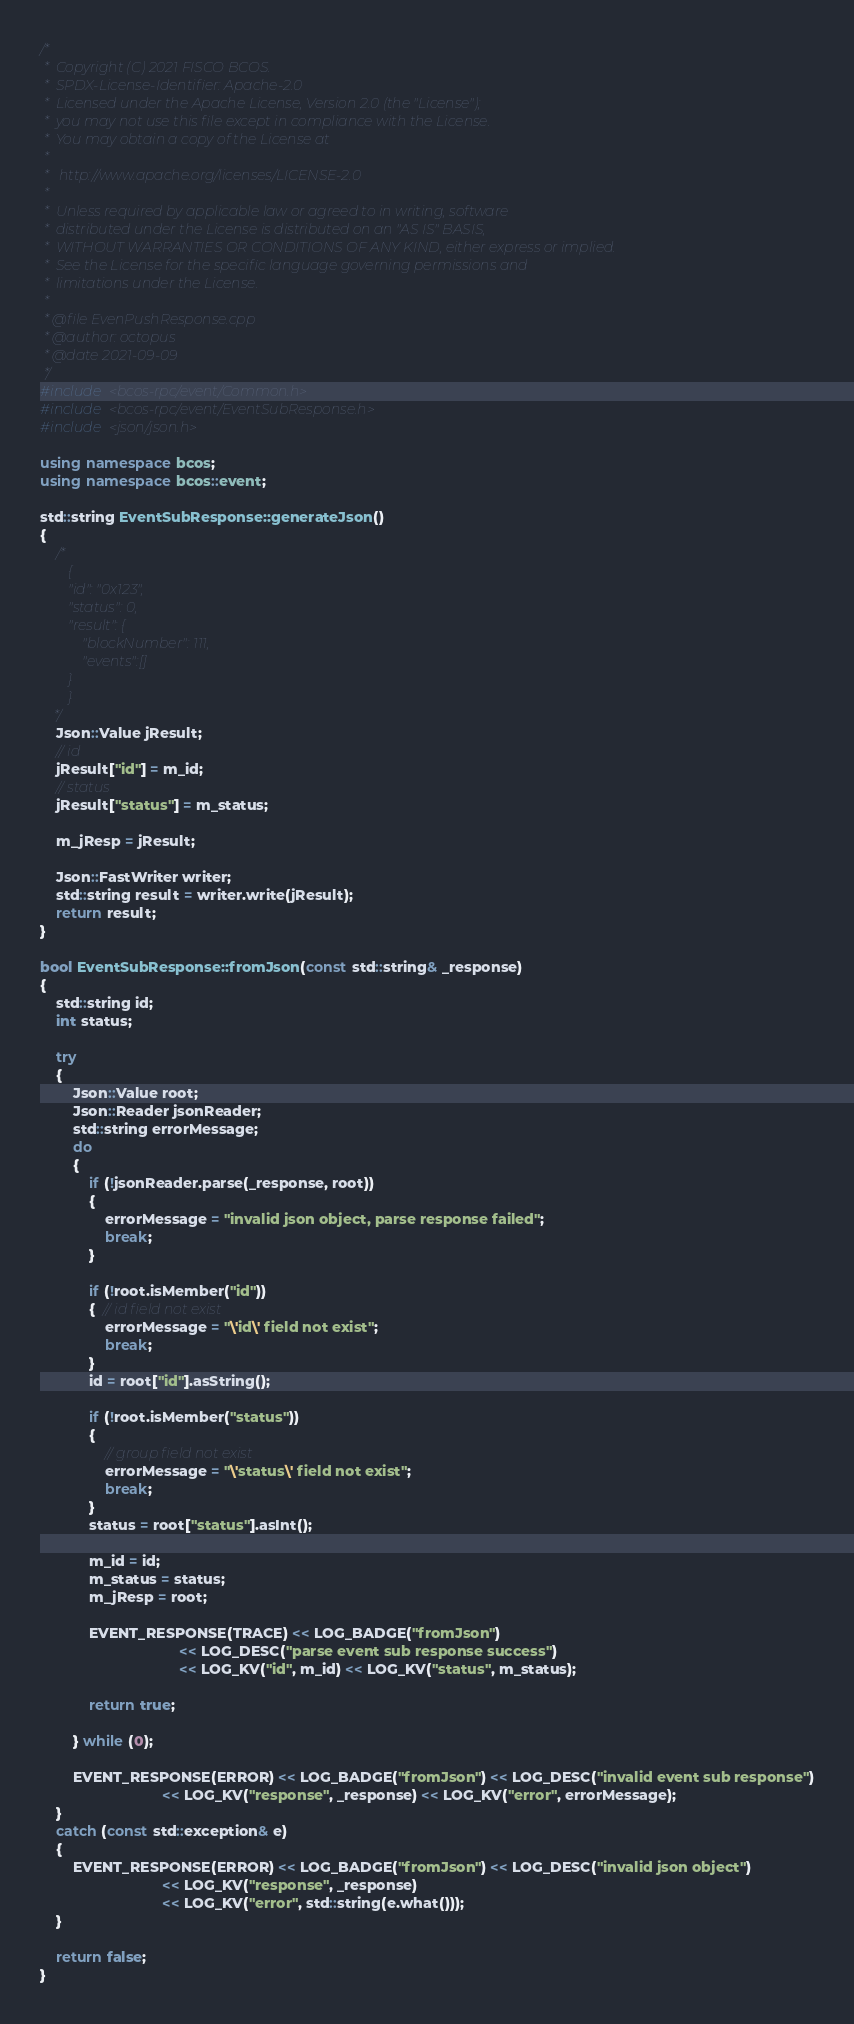Convert code to text. <code><loc_0><loc_0><loc_500><loc_500><_C++_>/*
 *  Copyright (C) 2021 FISCO BCOS.
 *  SPDX-License-Identifier: Apache-2.0
 *  Licensed under the Apache License, Version 2.0 (the "License");
 *  you may not use this file except in compliance with the License.
 *  You may obtain a copy of the License at
 *
 *   http://www.apache.org/licenses/LICENSE-2.0
 *
 *  Unless required by applicable law or agreed to in writing, software
 *  distributed under the License is distributed on an "AS IS" BASIS,
 *  WITHOUT WARRANTIES OR CONDITIONS OF ANY KIND, either express or implied.
 *  See the License for the specific language governing permissions and
 *  limitations under the License.
 *
 * @file EvenPushResponse.cpp
 * @author: octopus
 * @date 2021-09-09
 */
#include <bcos-rpc/event/Common.h>
#include <bcos-rpc/event/EventSubResponse.h>
#include <json/json.h>

using namespace bcos;
using namespace bcos::event;

std::string EventSubResponse::generateJson()
{
    /*
        {
        "id": "0x123",
        "status": 0,
        "result": {
            "blockNumber": 111,
            "events":[]
        }
        }
    */
    Json::Value jResult;
    // id
    jResult["id"] = m_id;
    // status
    jResult["status"] = m_status;

    m_jResp = jResult;

    Json::FastWriter writer;
    std::string result = writer.write(jResult);
    return result;
}

bool EventSubResponse::fromJson(const std::string& _response)
{
    std::string id;
    int status;

    try
    {
        Json::Value root;
        Json::Reader jsonReader;
        std::string errorMessage;
        do
        {
            if (!jsonReader.parse(_response, root))
            {
                errorMessage = "invalid json object, parse response failed";
                break;
            }

            if (!root.isMember("id"))
            {  // id field not exist
                errorMessage = "\'id\' field not exist";
                break;
            }
            id = root["id"].asString();

            if (!root.isMember("status"))
            {
                // group field not exist
                errorMessage = "\'status\' field not exist";
                break;
            }
            status = root["status"].asInt();

            m_id = id;
            m_status = status;
            m_jResp = root;

            EVENT_RESPONSE(TRACE) << LOG_BADGE("fromJson")
                                  << LOG_DESC("parse event sub response success")
                                  << LOG_KV("id", m_id) << LOG_KV("status", m_status);

            return true;

        } while (0);

        EVENT_RESPONSE(ERROR) << LOG_BADGE("fromJson") << LOG_DESC("invalid event sub response")
                              << LOG_KV("response", _response) << LOG_KV("error", errorMessage);
    }
    catch (const std::exception& e)
    {
        EVENT_RESPONSE(ERROR) << LOG_BADGE("fromJson") << LOG_DESC("invalid json object")
                              << LOG_KV("response", _response)
                              << LOG_KV("error", std::string(e.what()));
    }

    return false;
}
</code> 